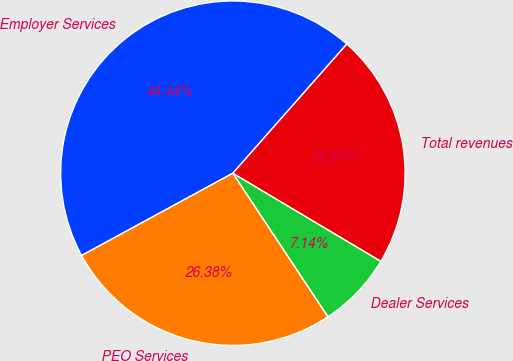Convert chart. <chart><loc_0><loc_0><loc_500><loc_500><pie_chart><fcel>Employer Services<fcel>PEO Services<fcel>Dealer Services<fcel>Total revenues<nl><fcel>44.44%<fcel>26.38%<fcel>7.14%<fcel>22.04%<nl></chart> 